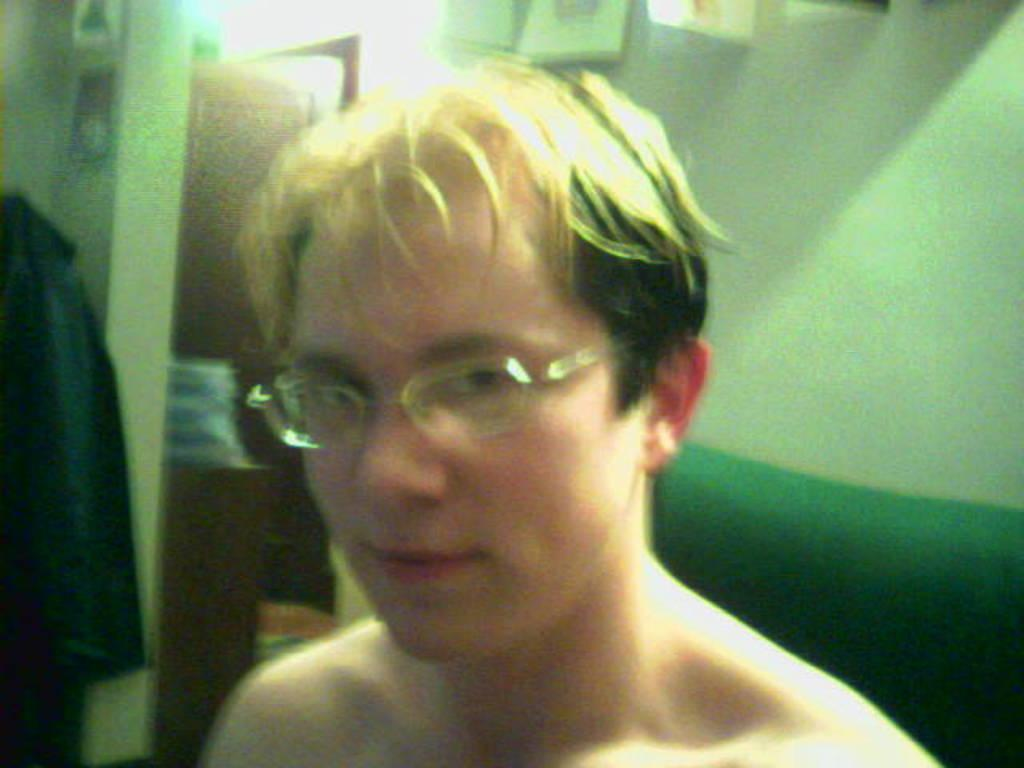Who is the main subject in the image? There is a man in the image. Can you describe the man's position in the image? The man is standing in the front. What is behind the man in the image? There is a wall behind the man. What architectural feature can be seen on the left side of the image? There is a door on the left side of the image. What is attached to the wall in the image? There are objects attached to the wall. What type of vegetable is being served by the man in the image? There is no vegetable being served in the image, nor is there a servant present. 